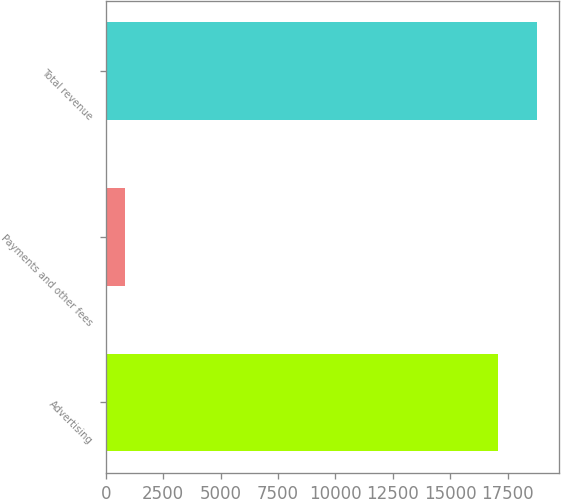<chart> <loc_0><loc_0><loc_500><loc_500><bar_chart><fcel>Advertising<fcel>Payments and other fees<fcel>Total revenue<nl><fcel>17079<fcel>849<fcel>18786.9<nl></chart> 